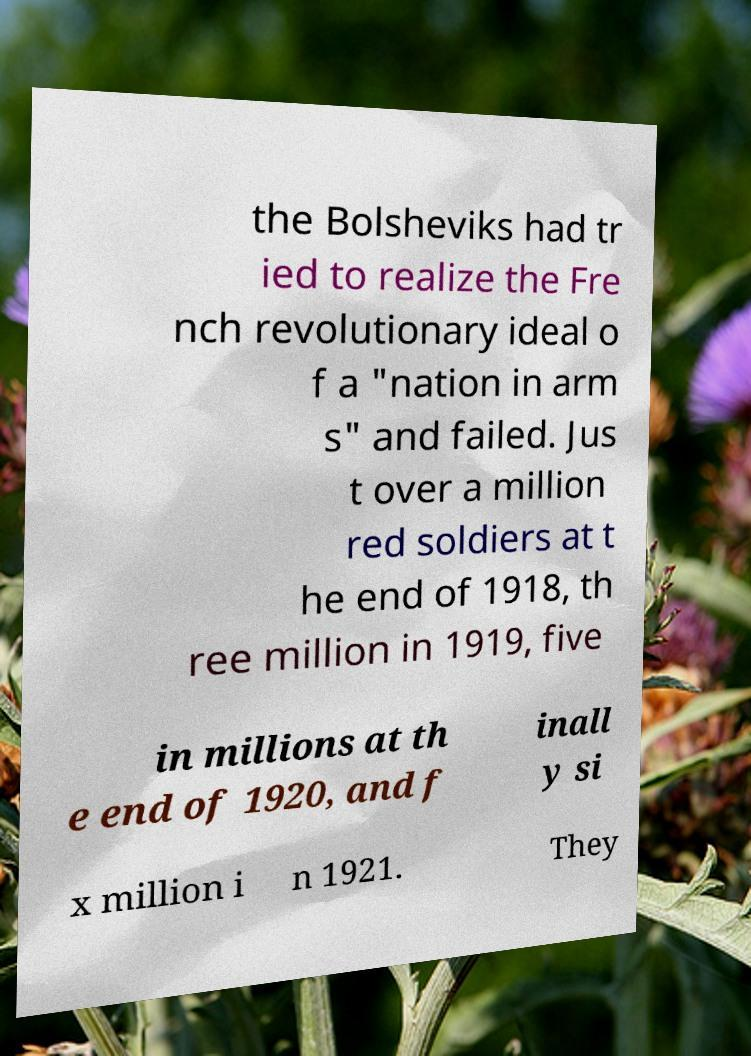Could you extract and type out the text from this image? the Bolsheviks had tr ied to realize the Fre nch revolutionary ideal o f a "nation in arm s" and failed. Jus t over a million red soldiers at t he end of 1918, th ree million in 1919, five in millions at th e end of 1920, and f inall y si x million i n 1921. They 